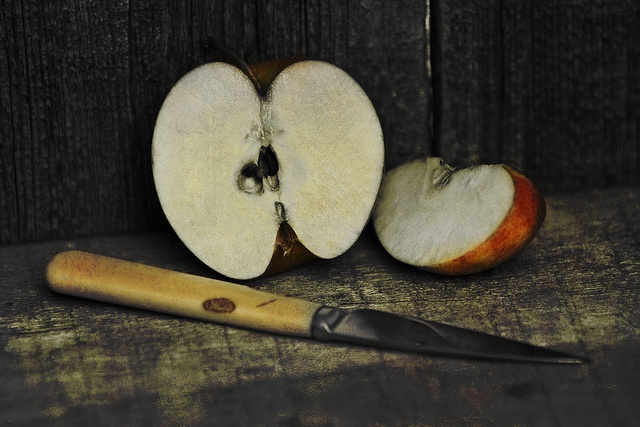Describe the objects in this image and their specific colors. I can see apple in black and tan tones, knife in black and olive tones, and apple in black, darkgray, gray, and maroon tones in this image. 